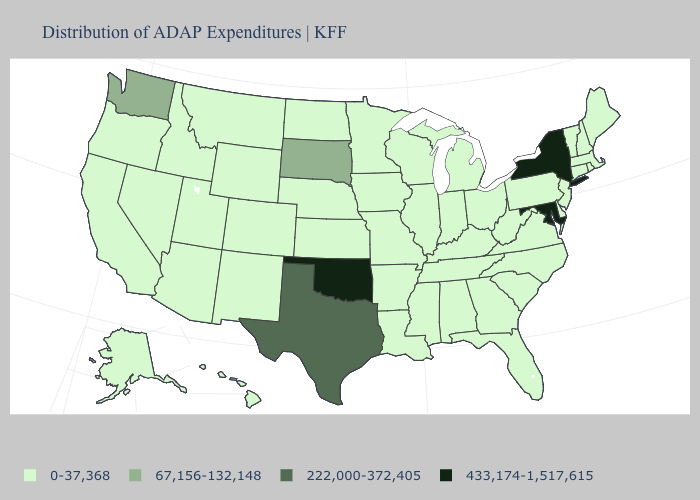Name the states that have a value in the range 67,156-132,148?
Quick response, please. South Dakota, Washington. What is the highest value in the MidWest ?
Short answer required. 67,156-132,148. What is the lowest value in states that border Nebraska?
Quick response, please. 0-37,368. How many symbols are there in the legend?
Write a very short answer. 4. What is the lowest value in the USA?
Be succinct. 0-37,368. What is the value of West Virginia?
Concise answer only. 0-37,368. Does Wyoming have the lowest value in the West?
Answer briefly. Yes. Name the states that have a value in the range 222,000-372,405?
Concise answer only. Texas. What is the highest value in states that border West Virginia?
Concise answer only. 433,174-1,517,615. Among the states that border Minnesota , which have the highest value?
Write a very short answer. South Dakota. Does the first symbol in the legend represent the smallest category?
Be succinct. Yes. What is the highest value in the South ?
Keep it brief. 433,174-1,517,615. What is the value of Maryland?
Give a very brief answer. 433,174-1,517,615. What is the highest value in the Northeast ?
Give a very brief answer. 433,174-1,517,615. What is the lowest value in states that border Utah?
Keep it brief. 0-37,368. 